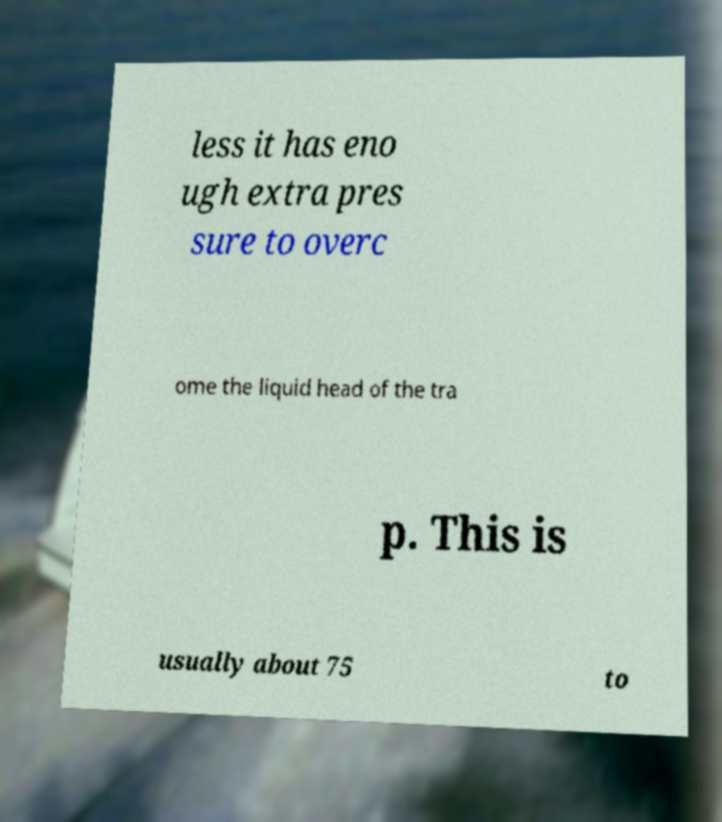Could you assist in decoding the text presented in this image and type it out clearly? less it has eno ugh extra pres sure to overc ome the liquid head of the tra p. This is usually about 75 to 